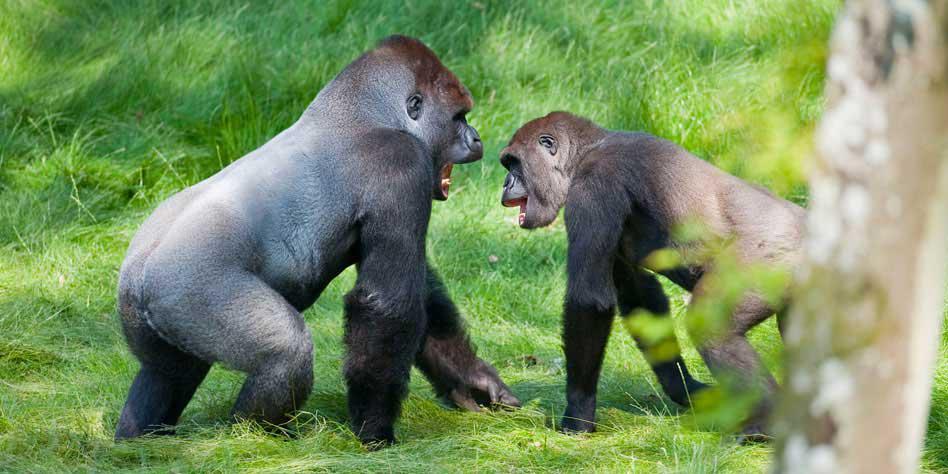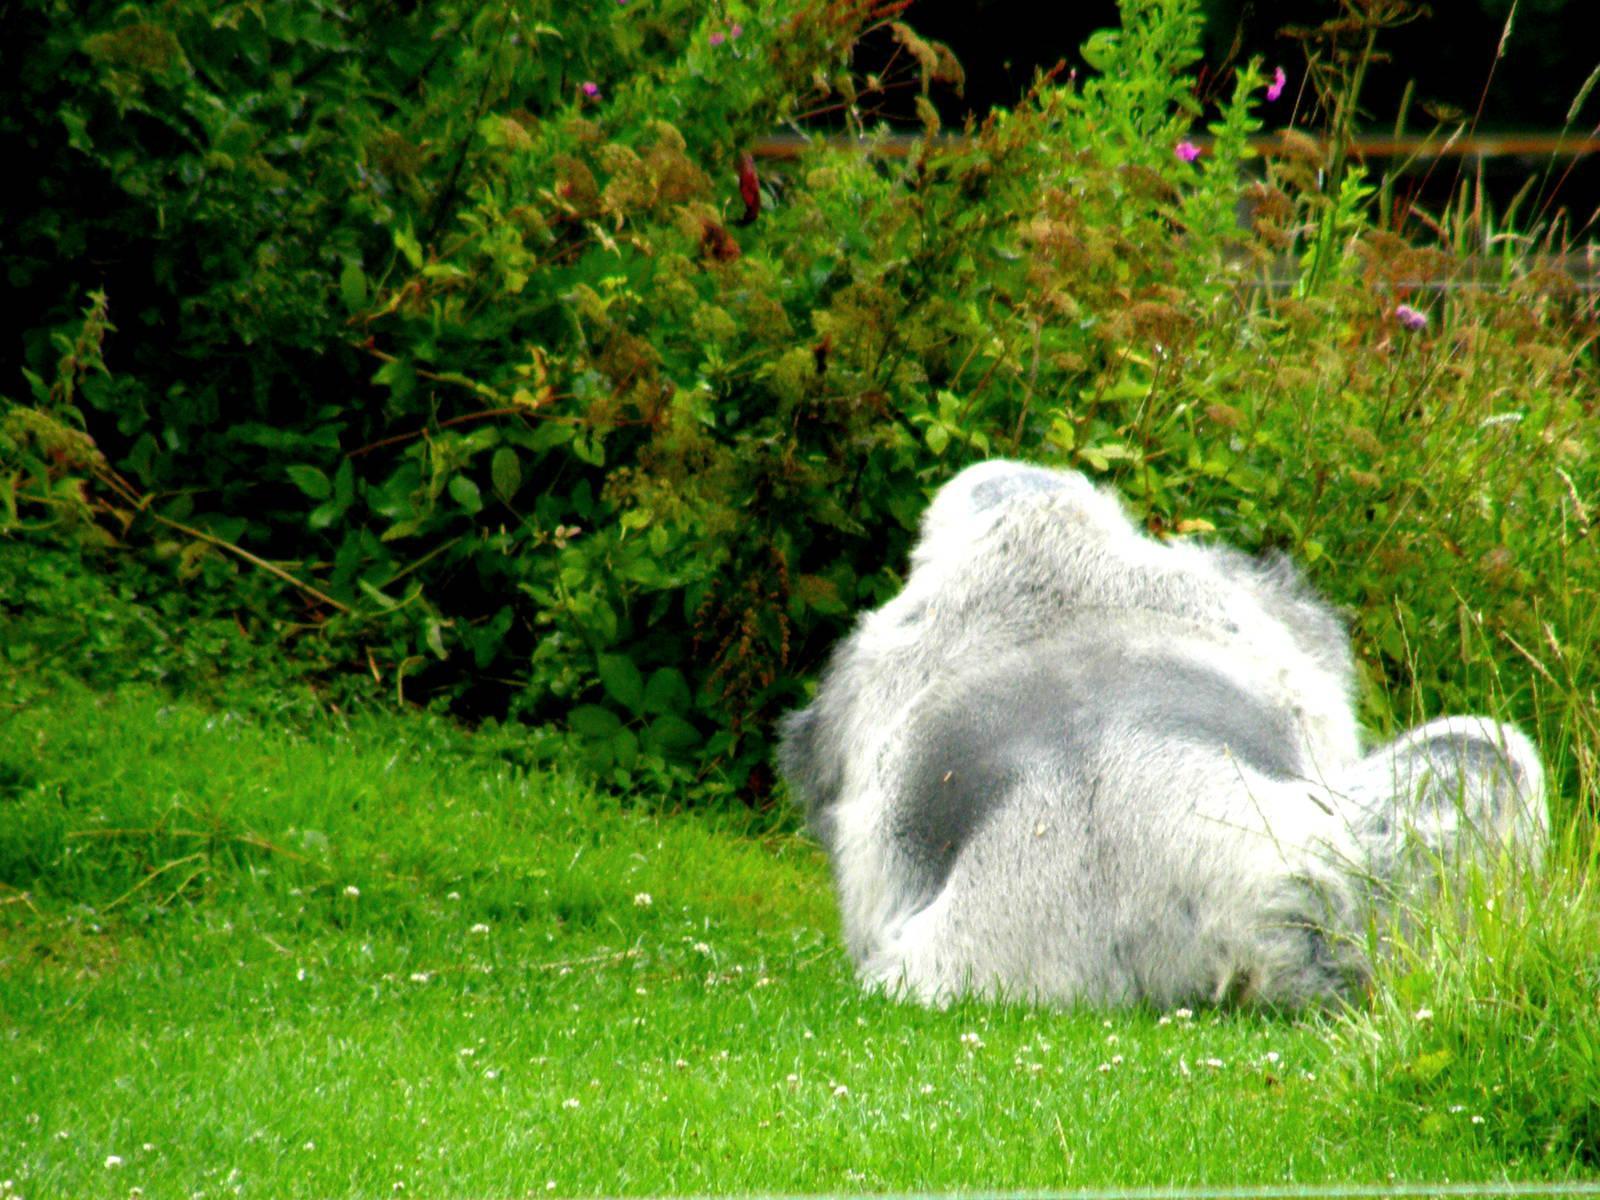The first image is the image on the left, the second image is the image on the right. Evaluate the accuracy of this statement regarding the images: "The gorilla in the right image is sitting in the grass near a bunch of weeds.". Is it true? Answer yes or no. Yes. The first image is the image on the left, the second image is the image on the right. Examine the images to the left and right. Is the description "One image includes a silverback gorilla on all fours, and the other shows a silverback gorilla sitting on green grass." accurate? Answer yes or no. Yes. 